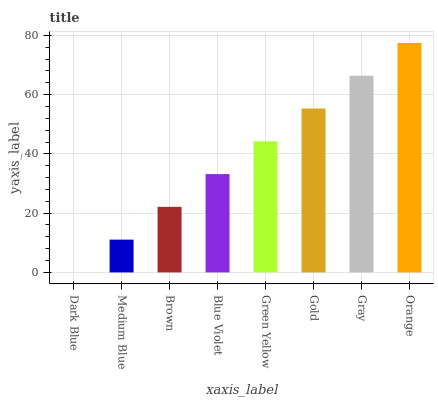Is Medium Blue the minimum?
Answer yes or no. No. Is Medium Blue the maximum?
Answer yes or no. No. Is Medium Blue greater than Dark Blue?
Answer yes or no. Yes. Is Dark Blue less than Medium Blue?
Answer yes or no. Yes. Is Dark Blue greater than Medium Blue?
Answer yes or no. No. Is Medium Blue less than Dark Blue?
Answer yes or no. No. Is Green Yellow the high median?
Answer yes or no. Yes. Is Blue Violet the low median?
Answer yes or no. Yes. Is Orange the high median?
Answer yes or no. No. Is Gray the low median?
Answer yes or no. No. 